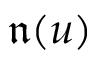<formula> <loc_0><loc_0><loc_500><loc_500>\mathfrak { n } ( u )</formula> 